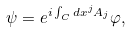Convert formula to latex. <formula><loc_0><loc_0><loc_500><loc_500>\psi = e ^ { i \int _ { C } d x ^ { j } A _ { j } } \varphi ,</formula> 